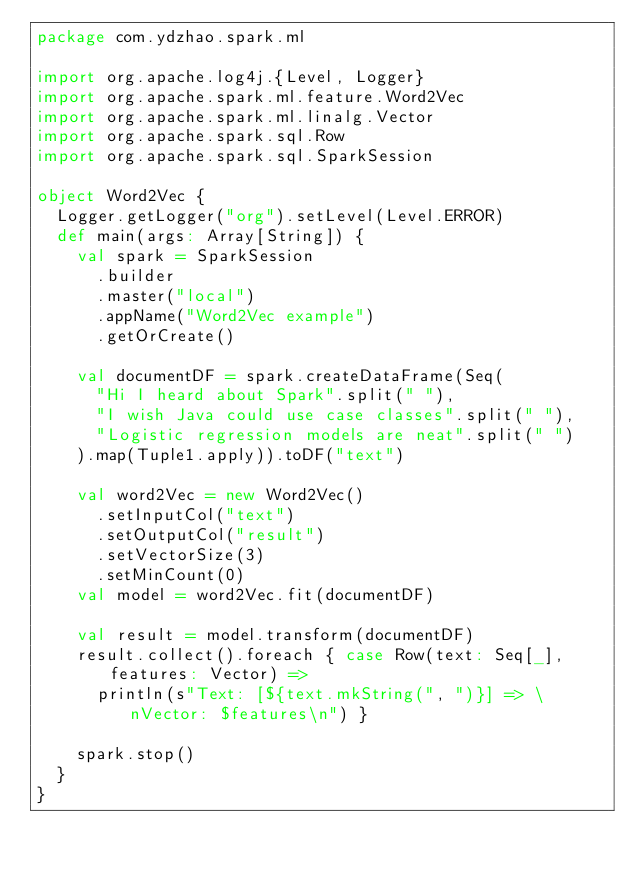Convert code to text. <code><loc_0><loc_0><loc_500><loc_500><_Scala_>package com.ydzhao.spark.ml

import org.apache.log4j.{Level, Logger}
import org.apache.spark.ml.feature.Word2Vec
import org.apache.spark.ml.linalg.Vector
import org.apache.spark.sql.Row
import org.apache.spark.sql.SparkSession

object Word2Vec {
  Logger.getLogger("org").setLevel(Level.ERROR)
  def main(args: Array[String]) {
    val spark = SparkSession
      .builder
      .master("local")
      .appName("Word2Vec example")
      .getOrCreate()

    val documentDF = spark.createDataFrame(Seq(
      "Hi I heard about Spark".split(" "),
      "I wish Java could use case classes".split(" "),
      "Logistic regression models are neat".split(" ")
    ).map(Tuple1.apply)).toDF("text")

    val word2Vec = new Word2Vec()
      .setInputCol("text")
      .setOutputCol("result")
      .setVectorSize(3)
      .setMinCount(0)
    val model = word2Vec.fit(documentDF)

    val result = model.transform(documentDF)
    result.collect().foreach { case Row(text: Seq[_], features: Vector) =>
      println(s"Text: [${text.mkString(", ")}] => \nVector: $features\n") }

    spark.stop()
  }
}
</code> 